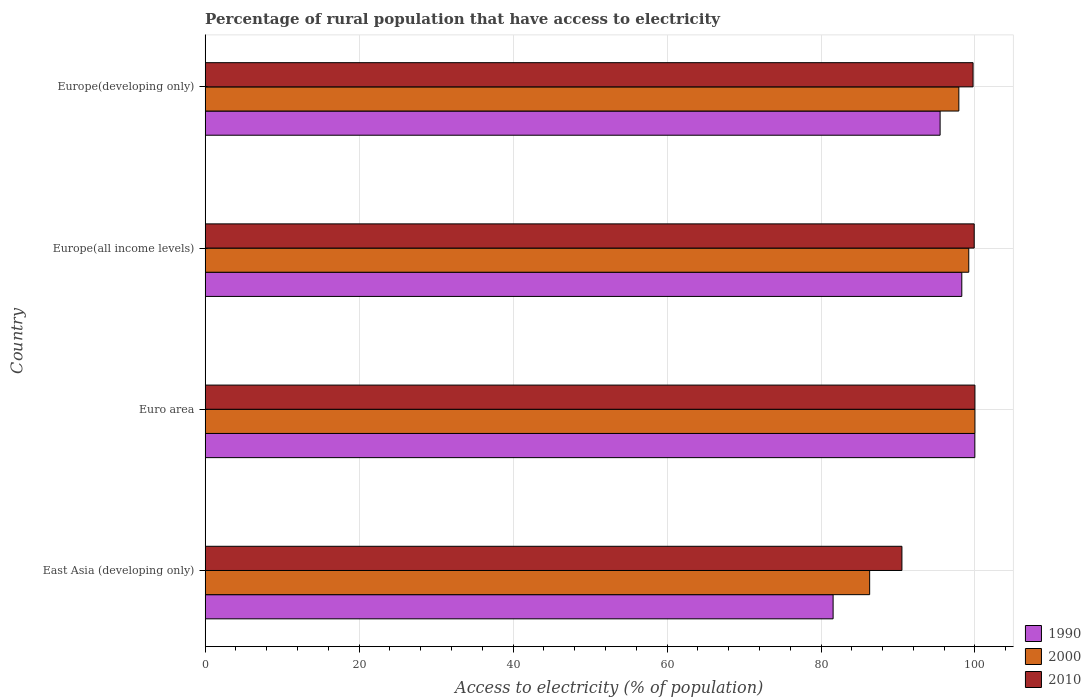Are the number of bars per tick equal to the number of legend labels?
Keep it short and to the point. Yes. Are the number of bars on each tick of the Y-axis equal?
Your response must be concise. Yes. How many bars are there on the 1st tick from the bottom?
Your answer should be very brief. 3. What is the label of the 1st group of bars from the top?
Ensure brevity in your answer.  Europe(developing only). What is the percentage of rural population that have access to electricity in 1990 in East Asia (developing only)?
Your response must be concise. 81.57. Across all countries, what is the minimum percentage of rural population that have access to electricity in 2010?
Your response must be concise. 90.51. In which country was the percentage of rural population that have access to electricity in 2010 minimum?
Offer a very short reply. East Asia (developing only). What is the total percentage of rural population that have access to electricity in 1990 in the graph?
Offer a very short reply. 375.33. What is the difference between the percentage of rural population that have access to electricity in 1990 in East Asia (developing only) and that in Europe(developing only)?
Offer a very short reply. -13.9. What is the difference between the percentage of rural population that have access to electricity in 2000 in Europe(all income levels) and the percentage of rural population that have access to electricity in 1990 in Europe(developing only)?
Offer a very short reply. 3.72. What is the average percentage of rural population that have access to electricity in 1990 per country?
Your answer should be compact. 93.83. What is the difference between the percentage of rural population that have access to electricity in 1990 and percentage of rural population that have access to electricity in 2010 in Europe(developing only)?
Your answer should be compact. -4.28. What is the ratio of the percentage of rural population that have access to electricity in 1990 in East Asia (developing only) to that in Europe(all income levels)?
Your answer should be compact. 0.83. Is the percentage of rural population that have access to electricity in 1990 in East Asia (developing only) less than that in Euro area?
Offer a terse response. Yes. What is the difference between the highest and the second highest percentage of rural population that have access to electricity in 2010?
Give a very brief answer. 0.1. What is the difference between the highest and the lowest percentage of rural population that have access to electricity in 1990?
Ensure brevity in your answer.  18.41. In how many countries, is the percentage of rural population that have access to electricity in 1990 greater than the average percentage of rural population that have access to electricity in 1990 taken over all countries?
Provide a short and direct response. 3. Is the sum of the percentage of rural population that have access to electricity in 2000 in East Asia (developing only) and Euro area greater than the maximum percentage of rural population that have access to electricity in 1990 across all countries?
Ensure brevity in your answer.  Yes. What does the 2nd bar from the top in Europe(developing only) represents?
Provide a succinct answer. 2000. What does the 2nd bar from the bottom in Europe(all income levels) represents?
Give a very brief answer. 2000. Are all the bars in the graph horizontal?
Offer a terse response. Yes. What is the difference between two consecutive major ticks on the X-axis?
Provide a short and direct response. 20. Are the values on the major ticks of X-axis written in scientific E-notation?
Make the answer very short. No. Where does the legend appear in the graph?
Offer a very short reply. Bottom right. How many legend labels are there?
Your answer should be very brief. 3. How are the legend labels stacked?
Make the answer very short. Vertical. What is the title of the graph?
Provide a short and direct response. Percentage of rural population that have access to electricity. Does "1976" appear as one of the legend labels in the graph?
Your answer should be very brief. No. What is the label or title of the X-axis?
Give a very brief answer. Access to electricity (% of population). What is the Access to electricity (% of population) in 1990 in East Asia (developing only)?
Offer a terse response. 81.57. What is the Access to electricity (% of population) of 2000 in East Asia (developing only)?
Make the answer very short. 86.32. What is the Access to electricity (% of population) of 2010 in East Asia (developing only)?
Keep it short and to the point. 90.51. What is the Access to electricity (% of population) of 1990 in Euro area?
Your answer should be very brief. 99.99. What is the Access to electricity (% of population) of 2000 in Euro area?
Give a very brief answer. 100. What is the Access to electricity (% of population) in 1990 in Europe(all income levels)?
Your answer should be very brief. 98.29. What is the Access to electricity (% of population) in 2000 in Europe(all income levels)?
Provide a succinct answer. 99.2. What is the Access to electricity (% of population) in 2010 in Europe(all income levels)?
Ensure brevity in your answer.  99.9. What is the Access to electricity (% of population) in 1990 in Europe(developing only)?
Your answer should be compact. 95.48. What is the Access to electricity (% of population) in 2000 in Europe(developing only)?
Provide a short and direct response. 97.91. What is the Access to electricity (% of population) in 2010 in Europe(developing only)?
Make the answer very short. 99.76. Across all countries, what is the maximum Access to electricity (% of population) in 1990?
Provide a succinct answer. 99.99. Across all countries, what is the maximum Access to electricity (% of population) in 2000?
Keep it short and to the point. 100. Across all countries, what is the minimum Access to electricity (% of population) in 1990?
Give a very brief answer. 81.57. Across all countries, what is the minimum Access to electricity (% of population) in 2000?
Offer a terse response. 86.32. Across all countries, what is the minimum Access to electricity (% of population) in 2010?
Offer a very short reply. 90.51. What is the total Access to electricity (% of population) of 1990 in the graph?
Give a very brief answer. 375.33. What is the total Access to electricity (% of population) of 2000 in the graph?
Offer a terse response. 383.43. What is the total Access to electricity (% of population) in 2010 in the graph?
Your answer should be compact. 390.17. What is the difference between the Access to electricity (% of population) of 1990 in East Asia (developing only) and that in Euro area?
Ensure brevity in your answer.  -18.41. What is the difference between the Access to electricity (% of population) of 2000 in East Asia (developing only) and that in Euro area?
Offer a terse response. -13.68. What is the difference between the Access to electricity (% of population) of 2010 in East Asia (developing only) and that in Euro area?
Offer a terse response. -9.49. What is the difference between the Access to electricity (% of population) in 1990 in East Asia (developing only) and that in Europe(all income levels)?
Your answer should be very brief. -16.72. What is the difference between the Access to electricity (% of population) of 2000 in East Asia (developing only) and that in Europe(all income levels)?
Make the answer very short. -12.88. What is the difference between the Access to electricity (% of population) in 2010 in East Asia (developing only) and that in Europe(all income levels)?
Make the answer very short. -9.39. What is the difference between the Access to electricity (% of population) in 1990 in East Asia (developing only) and that in Europe(developing only)?
Make the answer very short. -13.9. What is the difference between the Access to electricity (% of population) of 2000 in East Asia (developing only) and that in Europe(developing only)?
Make the answer very short. -11.59. What is the difference between the Access to electricity (% of population) of 2010 in East Asia (developing only) and that in Europe(developing only)?
Offer a very short reply. -9.24. What is the difference between the Access to electricity (% of population) of 1990 in Euro area and that in Europe(all income levels)?
Offer a terse response. 1.7. What is the difference between the Access to electricity (% of population) in 2000 in Euro area and that in Europe(all income levels)?
Your answer should be compact. 0.8. What is the difference between the Access to electricity (% of population) in 2010 in Euro area and that in Europe(all income levels)?
Your response must be concise. 0.1. What is the difference between the Access to electricity (% of population) in 1990 in Euro area and that in Europe(developing only)?
Give a very brief answer. 4.51. What is the difference between the Access to electricity (% of population) in 2000 in Euro area and that in Europe(developing only)?
Offer a very short reply. 2.09. What is the difference between the Access to electricity (% of population) of 2010 in Euro area and that in Europe(developing only)?
Make the answer very short. 0.24. What is the difference between the Access to electricity (% of population) in 1990 in Europe(all income levels) and that in Europe(developing only)?
Your answer should be very brief. 2.82. What is the difference between the Access to electricity (% of population) in 2000 in Europe(all income levels) and that in Europe(developing only)?
Your answer should be very brief. 1.29. What is the difference between the Access to electricity (% of population) in 2010 in Europe(all income levels) and that in Europe(developing only)?
Make the answer very short. 0.15. What is the difference between the Access to electricity (% of population) in 1990 in East Asia (developing only) and the Access to electricity (% of population) in 2000 in Euro area?
Keep it short and to the point. -18.43. What is the difference between the Access to electricity (% of population) of 1990 in East Asia (developing only) and the Access to electricity (% of population) of 2010 in Euro area?
Make the answer very short. -18.43. What is the difference between the Access to electricity (% of population) in 2000 in East Asia (developing only) and the Access to electricity (% of population) in 2010 in Euro area?
Provide a succinct answer. -13.68. What is the difference between the Access to electricity (% of population) in 1990 in East Asia (developing only) and the Access to electricity (% of population) in 2000 in Europe(all income levels)?
Make the answer very short. -17.62. What is the difference between the Access to electricity (% of population) in 1990 in East Asia (developing only) and the Access to electricity (% of population) in 2010 in Europe(all income levels)?
Keep it short and to the point. -18.33. What is the difference between the Access to electricity (% of population) of 2000 in East Asia (developing only) and the Access to electricity (% of population) of 2010 in Europe(all income levels)?
Your answer should be compact. -13.58. What is the difference between the Access to electricity (% of population) of 1990 in East Asia (developing only) and the Access to electricity (% of population) of 2000 in Europe(developing only)?
Provide a short and direct response. -16.33. What is the difference between the Access to electricity (% of population) in 1990 in East Asia (developing only) and the Access to electricity (% of population) in 2010 in Europe(developing only)?
Your response must be concise. -18.18. What is the difference between the Access to electricity (% of population) of 2000 in East Asia (developing only) and the Access to electricity (% of population) of 2010 in Europe(developing only)?
Provide a short and direct response. -13.43. What is the difference between the Access to electricity (% of population) in 1990 in Euro area and the Access to electricity (% of population) in 2000 in Europe(all income levels)?
Keep it short and to the point. 0.79. What is the difference between the Access to electricity (% of population) in 1990 in Euro area and the Access to electricity (% of population) in 2010 in Europe(all income levels)?
Give a very brief answer. 0.08. What is the difference between the Access to electricity (% of population) of 2000 in Euro area and the Access to electricity (% of population) of 2010 in Europe(all income levels)?
Your answer should be compact. 0.1. What is the difference between the Access to electricity (% of population) in 1990 in Euro area and the Access to electricity (% of population) in 2000 in Europe(developing only)?
Offer a terse response. 2.08. What is the difference between the Access to electricity (% of population) in 1990 in Euro area and the Access to electricity (% of population) in 2010 in Europe(developing only)?
Provide a succinct answer. 0.23. What is the difference between the Access to electricity (% of population) of 2000 in Euro area and the Access to electricity (% of population) of 2010 in Europe(developing only)?
Give a very brief answer. 0.24. What is the difference between the Access to electricity (% of population) in 1990 in Europe(all income levels) and the Access to electricity (% of population) in 2000 in Europe(developing only)?
Your answer should be compact. 0.38. What is the difference between the Access to electricity (% of population) of 1990 in Europe(all income levels) and the Access to electricity (% of population) of 2010 in Europe(developing only)?
Give a very brief answer. -1.46. What is the difference between the Access to electricity (% of population) in 2000 in Europe(all income levels) and the Access to electricity (% of population) in 2010 in Europe(developing only)?
Make the answer very short. -0.56. What is the average Access to electricity (% of population) of 1990 per country?
Keep it short and to the point. 93.83. What is the average Access to electricity (% of population) of 2000 per country?
Ensure brevity in your answer.  95.86. What is the average Access to electricity (% of population) in 2010 per country?
Offer a terse response. 97.54. What is the difference between the Access to electricity (% of population) of 1990 and Access to electricity (% of population) of 2000 in East Asia (developing only)?
Your answer should be very brief. -4.75. What is the difference between the Access to electricity (% of population) in 1990 and Access to electricity (% of population) in 2010 in East Asia (developing only)?
Your response must be concise. -8.94. What is the difference between the Access to electricity (% of population) of 2000 and Access to electricity (% of population) of 2010 in East Asia (developing only)?
Make the answer very short. -4.19. What is the difference between the Access to electricity (% of population) of 1990 and Access to electricity (% of population) of 2000 in Euro area?
Offer a terse response. -0.01. What is the difference between the Access to electricity (% of population) in 1990 and Access to electricity (% of population) in 2010 in Euro area?
Make the answer very short. -0.01. What is the difference between the Access to electricity (% of population) of 2000 and Access to electricity (% of population) of 2010 in Euro area?
Provide a short and direct response. 0. What is the difference between the Access to electricity (% of population) of 1990 and Access to electricity (% of population) of 2000 in Europe(all income levels)?
Offer a terse response. -0.91. What is the difference between the Access to electricity (% of population) in 1990 and Access to electricity (% of population) in 2010 in Europe(all income levels)?
Provide a succinct answer. -1.61. What is the difference between the Access to electricity (% of population) of 2000 and Access to electricity (% of population) of 2010 in Europe(all income levels)?
Provide a succinct answer. -0.71. What is the difference between the Access to electricity (% of population) in 1990 and Access to electricity (% of population) in 2000 in Europe(developing only)?
Keep it short and to the point. -2.43. What is the difference between the Access to electricity (% of population) of 1990 and Access to electricity (% of population) of 2010 in Europe(developing only)?
Provide a short and direct response. -4.28. What is the difference between the Access to electricity (% of population) of 2000 and Access to electricity (% of population) of 2010 in Europe(developing only)?
Offer a very short reply. -1.85. What is the ratio of the Access to electricity (% of population) of 1990 in East Asia (developing only) to that in Euro area?
Your answer should be compact. 0.82. What is the ratio of the Access to electricity (% of population) of 2000 in East Asia (developing only) to that in Euro area?
Give a very brief answer. 0.86. What is the ratio of the Access to electricity (% of population) in 2010 in East Asia (developing only) to that in Euro area?
Your answer should be compact. 0.91. What is the ratio of the Access to electricity (% of population) of 1990 in East Asia (developing only) to that in Europe(all income levels)?
Ensure brevity in your answer.  0.83. What is the ratio of the Access to electricity (% of population) in 2000 in East Asia (developing only) to that in Europe(all income levels)?
Offer a terse response. 0.87. What is the ratio of the Access to electricity (% of population) in 2010 in East Asia (developing only) to that in Europe(all income levels)?
Make the answer very short. 0.91. What is the ratio of the Access to electricity (% of population) in 1990 in East Asia (developing only) to that in Europe(developing only)?
Provide a succinct answer. 0.85. What is the ratio of the Access to electricity (% of population) of 2000 in East Asia (developing only) to that in Europe(developing only)?
Your answer should be compact. 0.88. What is the ratio of the Access to electricity (% of population) of 2010 in East Asia (developing only) to that in Europe(developing only)?
Give a very brief answer. 0.91. What is the ratio of the Access to electricity (% of population) of 1990 in Euro area to that in Europe(all income levels)?
Ensure brevity in your answer.  1.02. What is the ratio of the Access to electricity (% of population) in 2000 in Euro area to that in Europe(all income levels)?
Give a very brief answer. 1.01. What is the ratio of the Access to electricity (% of population) in 1990 in Euro area to that in Europe(developing only)?
Provide a short and direct response. 1.05. What is the ratio of the Access to electricity (% of population) in 2000 in Euro area to that in Europe(developing only)?
Offer a very short reply. 1.02. What is the ratio of the Access to electricity (% of population) in 1990 in Europe(all income levels) to that in Europe(developing only)?
Your response must be concise. 1.03. What is the ratio of the Access to electricity (% of population) in 2000 in Europe(all income levels) to that in Europe(developing only)?
Your answer should be very brief. 1.01. What is the ratio of the Access to electricity (% of population) in 2010 in Europe(all income levels) to that in Europe(developing only)?
Your answer should be compact. 1. What is the difference between the highest and the second highest Access to electricity (% of population) in 1990?
Give a very brief answer. 1.7. What is the difference between the highest and the second highest Access to electricity (% of population) of 2000?
Offer a terse response. 0.8. What is the difference between the highest and the second highest Access to electricity (% of population) in 2010?
Ensure brevity in your answer.  0.1. What is the difference between the highest and the lowest Access to electricity (% of population) of 1990?
Give a very brief answer. 18.41. What is the difference between the highest and the lowest Access to electricity (% of population) of 2000?
Ensure brevity in your answer.  13.68. What is the difference between the highest and the lowest Access to electricity (% of population) of 2010?
Ensure brevity in your answer.  9.49. 